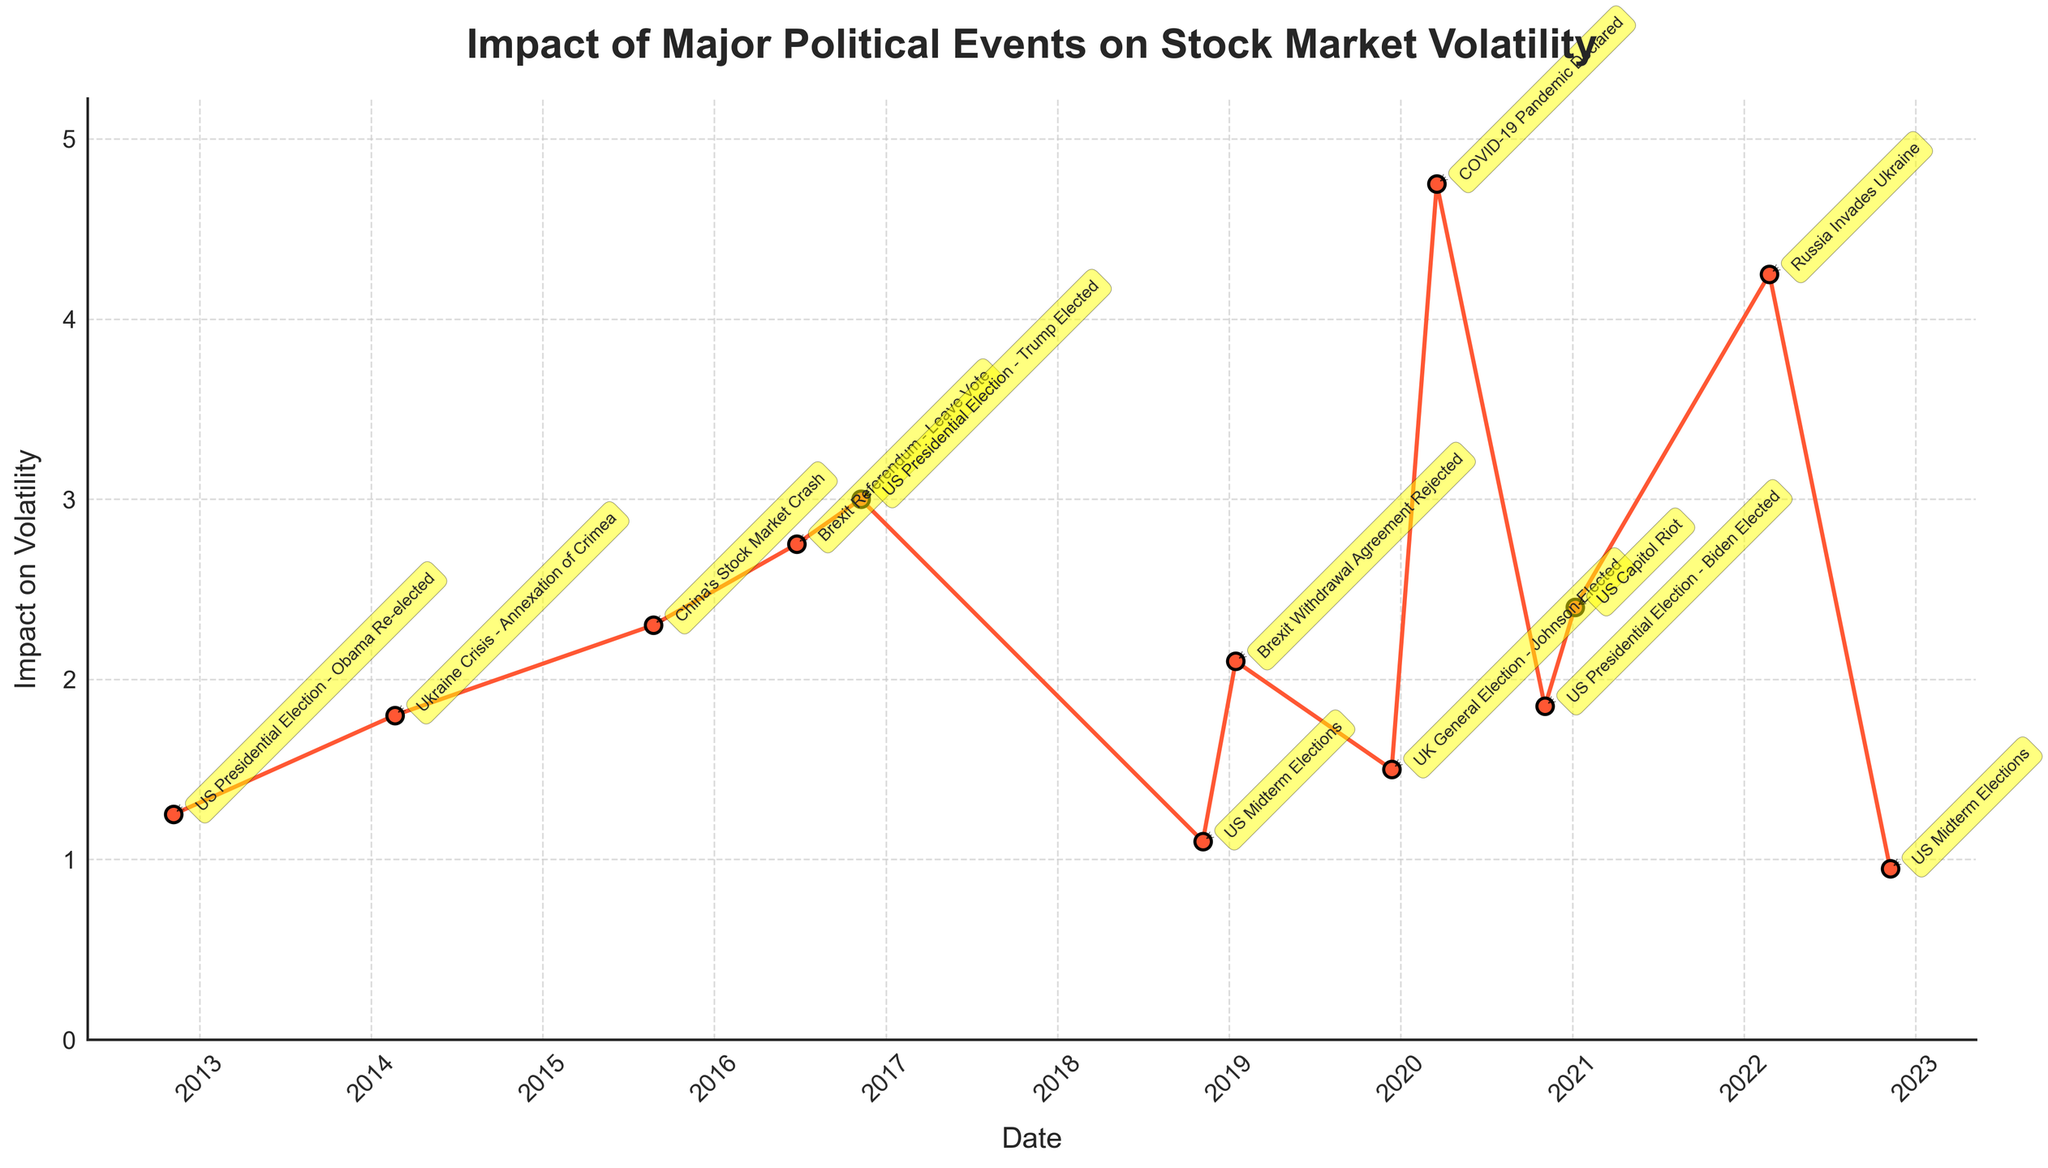What is the title of the plot? The title is displayed at the top of the plot, typically in a larger and bold font. It reads: "Impact of Major Political Events on Stock Market Volatility".
Answer: Impact of Major Political Events on Stock Market Volatility Which event caused the highest impact on volatility, and what was the value? The event with the highest impact is at the peak of the plot. It is labeled and annotated. The "COVID-19 Pandemic Declared" in March 2020 caused the highest impact, with a volatility level of 4.75.
Answer: COVID-19 Pandemic Declared, 4.75 How many major political events are plotted in the figure? You can count the data points or annotations on the plot. There are annotations for each event that indicate a total of 13 major political events.
Answer: 13 How does the impact of the US Presidential Election in 2020 compare to the US Midterm Elections in 2022? Locate the annotations for the US Presidential Election (November 2020) and US Midterm Elections (November 2022). Compare their values. The impact in 2020 is 1.85, while in 2022 it is 0.95, showing a higher impact in 2020.
Answer: US Presidential Election (1.85) is higher than US Midterm Elections (0.95) What is the average impact on volatility for all the events listed? Sum all the impact values and divide by the number of events. ((1.25 + 1.80 + 2.30 + 2.75 + 3.00 + 1.10 + 2.10 + 1.50 + 4.75 + 1.85 + 2.40 + 4.25 + 0.95) / 13 = 2.32)
Answer: 2.32 What is the difference in impact on volatility between Brexit Referendum - Leave Vote and UK's General Election - Johnson Elected? Subtract the impact value of the UK's General Election from the Brexit Referendum's value. (2.75 - 1.50 = 1.25)
Answer: 1.25 Which event had the least impact on volatility, and what was the value? The event with the lowest impact can be identified by the smallest value on the y-axis. It is labeled as the US Midterm Elections in November 2022 with an impact value of 0.95.
Answer: US Midterm Elections, 0.95 Did any event in 2019 have an impact greater than 2.0 on volatility? Check the annotations for 2019. The Brexit Withdrawal Agreement Rejected in January 2019 had an impact value of 2.10, which is greater than 2.0.
Answer: Yes, Brexit Withdrawal Agreement Rejected (2.10) What is the cumulative impact on volatility of all US Presidential Elections mentioned in the plot? Add the impact values of all US Presidential Elections: 2012 (1.25), 2016 (3.00), and 2020 (1.85). (1.25 + 3.00 + 1.85 = 6.10)
Answer: 6.10 Which event had a higher impact on volatility: Russia Invades Ukraine in 2022 or Ukraine Crisis - Annexation of Crimea in 2014? Compare the impact values: Russia Invades Ukraine (4.25) versus Ukraine Crisis - Annexation of Crimea (1.80). The invasion in 2022 had a higher impact.
Answer: Russia Invades Ukraine, 4.25 